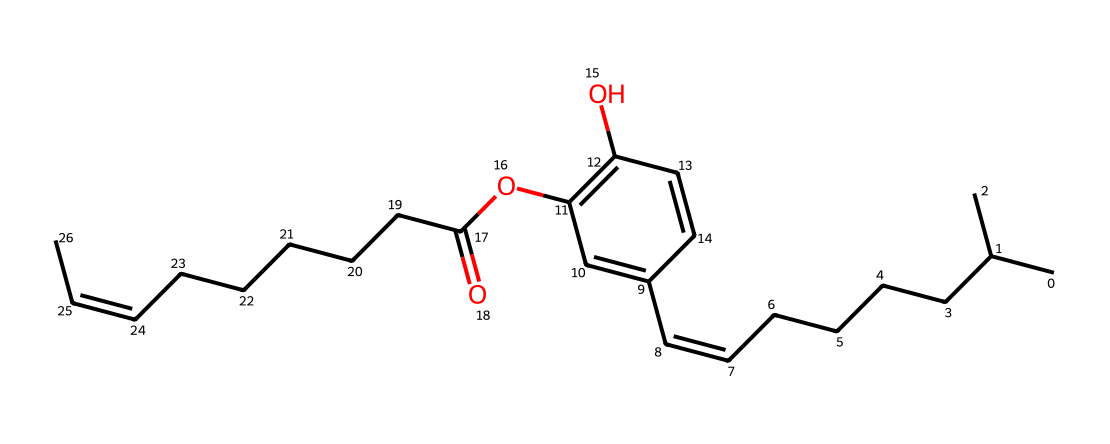how many carbon atoms are present in capsaicin? Count the number of carbon (C) atoms in the provided SMILES representation. Each "C" represents a carbon atom. Based on the structural information in the SMILES, there are 18 carbon atoms.
Answer: 18 what functional groups are present in capsaicin? Analyze the SMILES representation for distinct functional groups. Capsaicin contains a hydroxyl (-OH) group represented by "O" and a methoxy (-O-CH3) group. Therefore, the presence of these groups indicates the functional groups in the molecule.
Answer: hydroxyl, methoxy does capsaicin contain any double bonds? Examine the structure for any "=" signs indicating double bonds between atoms. The SMILES shows two instances of "/C=C/", confirming the presence of double bonds in the molecular structure.
Answer: yes what is the molecular formula of capsaicin? To determine the molecular formula, identify and count the number of each type of atom present in the molecule: 18 carbon (C), 27 hydrogen (H), and 3 oxygen (O) atoms, leading to the formula C18H27O3.
Answer: C18H27O3 is capsaicin an imide? Recall the defining characteristics of imides, which generally contain a carbonyl (C=O) bonded to two nitrogen (N) atoms. Analyze the structure: capsaicin lacks a nitrogen atom and the distinctive carbonyl group needed for imides. Thus, it is not classified as an imide.
Answer: no 